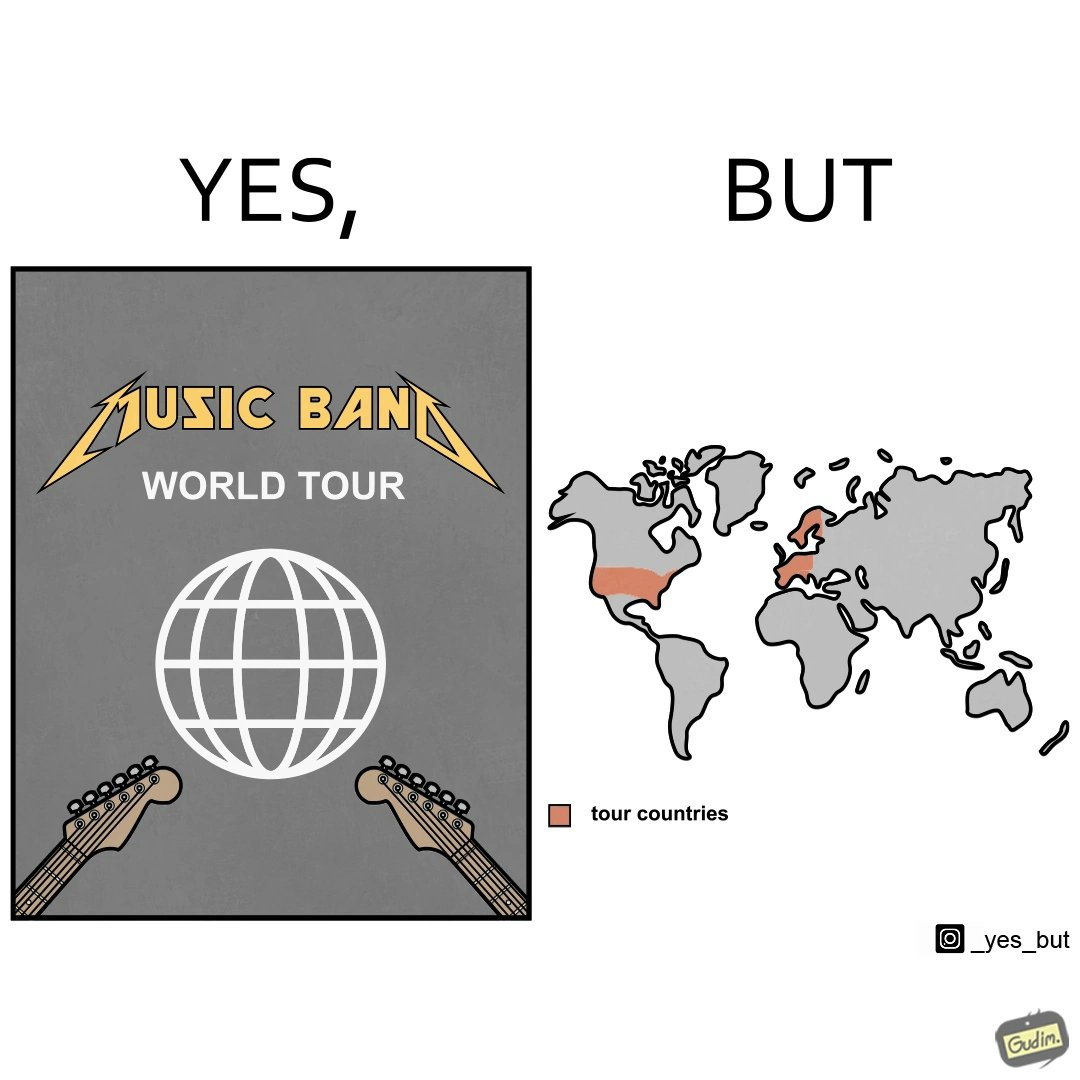Would you classify this image as satirical? Yes, this image is satirical. 